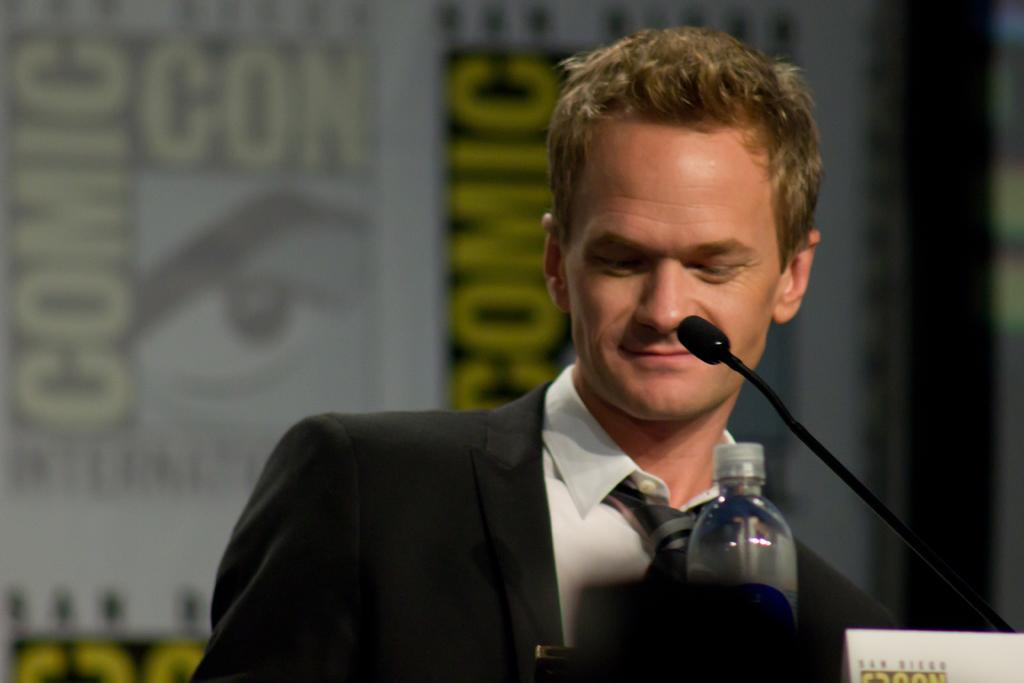Who is the main subject in the image? There is a man in the image. What is the man doing in the image? The man is standing in front of a mic. What can be seen on the table beside the mic? There is a water bottle on the table beside the mic. What is visible in the background of the image? There is a wall in the background of the image. How many oranges are on the table in the image? There are no oranges present in the image. What type of rock is visible in the background of the image? There is no rock visible in the background of the image; it is a wall. 